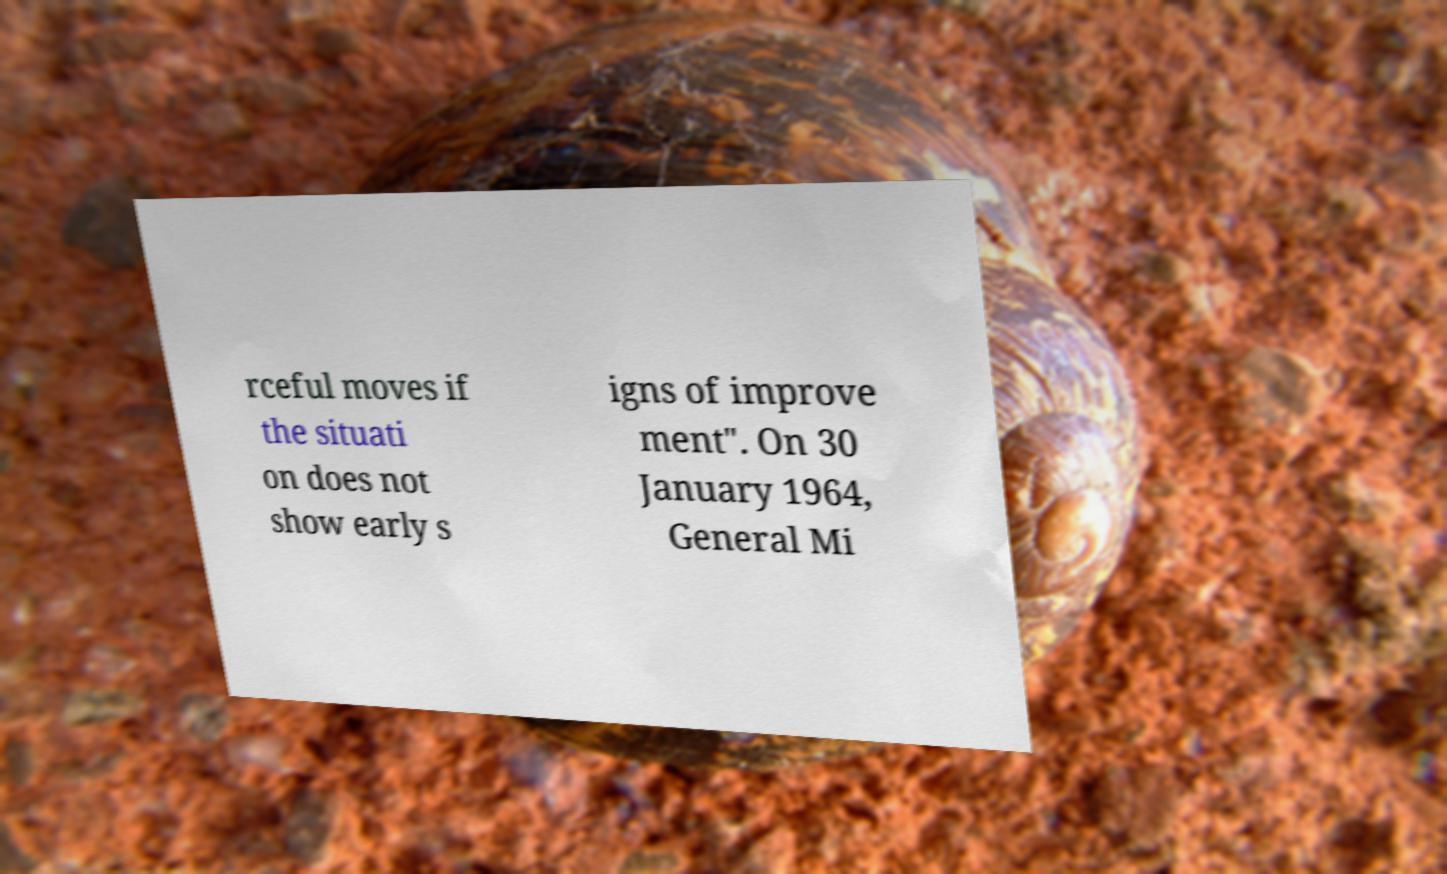Could you assist in decoding the text presented in this image and type it out clearly? rceful moves if the situati on does not show early s igns of improve ment". On 30 January 1964, General Mi 